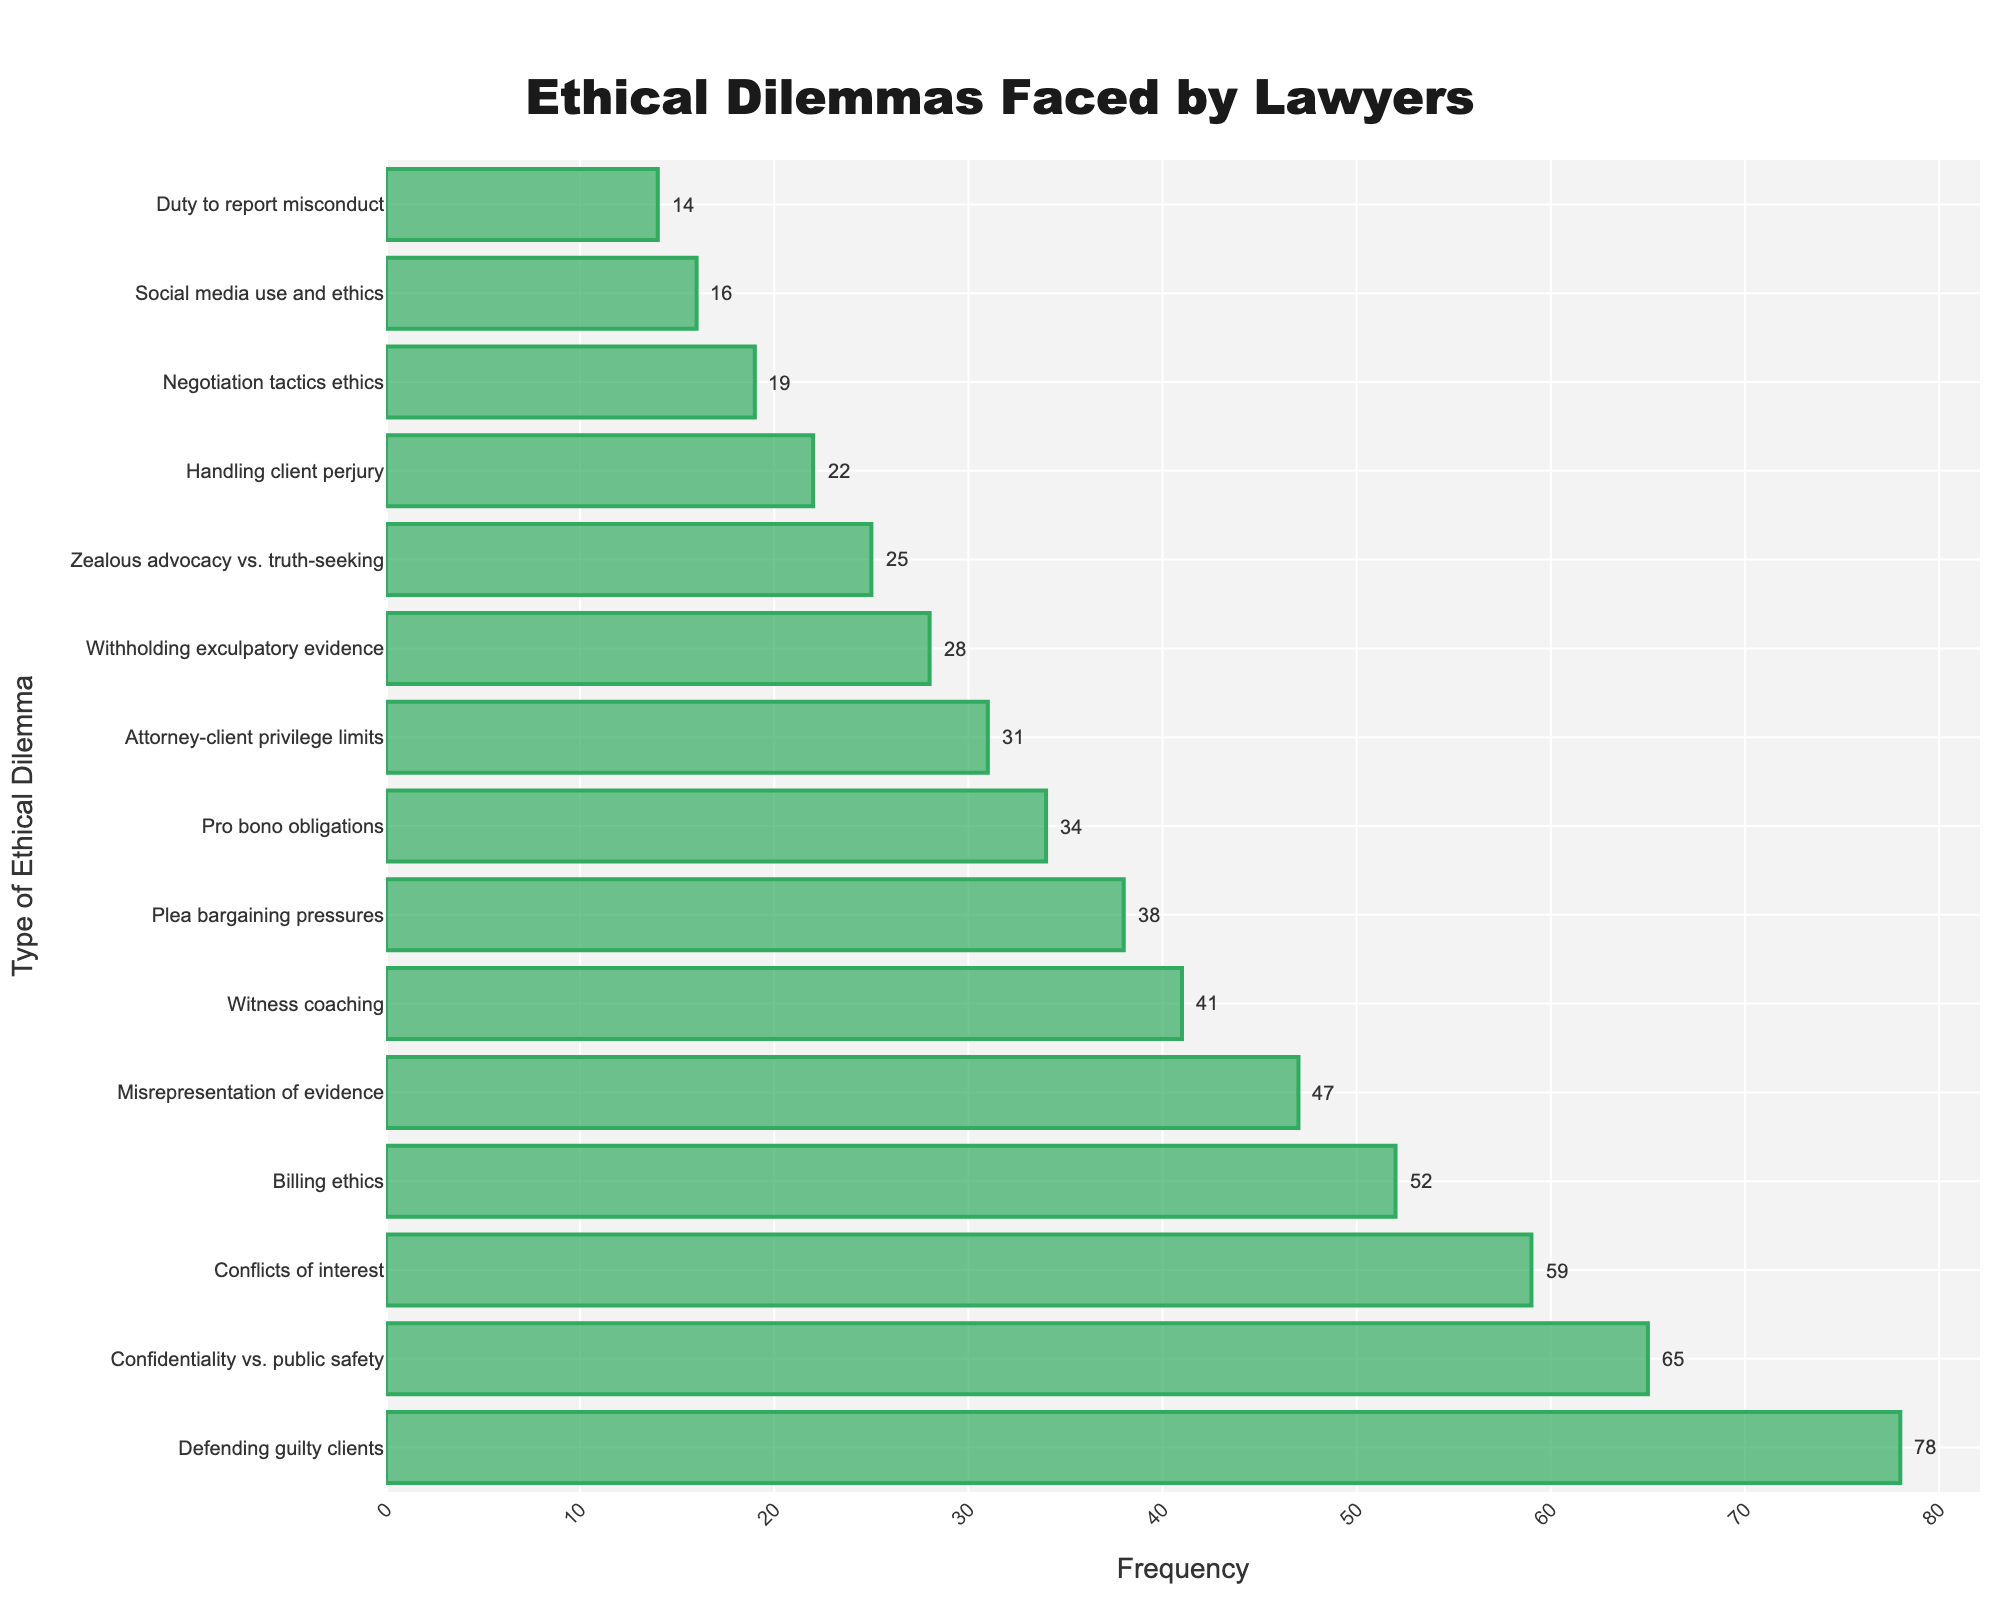Which ethical dilemma has the highest frequency? The bar representing "Defending guilty clients" is the longest bar, indicating it has the highest frequency.
Answer: Defending guilty clients What is the difference in frequency between "Defending guilty clients" and "Confidentiality vs. public safety"? The frequency for "Defending guilty clients" is 78 and for "Confidentiality vs. public safety" is 65. The difference is 78 - 65 = 13.
Answer: 13 How many ethical dilemmas have a frequency greater than 50? By observing the bars, the ethical dilemmas with frequencies greater than 50 are "Defending guilty clients," "Confidentiality vs. public safety," "Conflicts of interest," and "Billing ethics." There are 4 such dilemmas.
Answer: 4 What is the average frequency of the ethical dilemmas? Sum all the frequencies and divide by the number of dilemmas: (78 + 65 + 59 + 52 + 47 + 41 + 38 + 34 + 31 + 28 + 25 + 22 + 19 + 16 + 14) / 15 = 569 / 15 ≈ 37.93.
Answer: 37.93 How does the frequency of "Handling client perjury" compare to "Negotiation tactics ethics"? The frequency of "Handling client perjury" is 22, and for "Negotiation tactics ethics" it is 19. 22 is greater than 19 by 3.
Answer: Handling client perjury is greater by 3 What is the median frequency of the ethical dilemmas? After sorting the frequencies in ascending order (14, 16, 19, 22, 25, 28, 31, 34, 38, 41, 47, 52, 59, 65, 78), the median is the middle value: 34.
Answer: 34 What proportion of the ethical dilemmas have a frequency less than 30? Ethical dilemmas with frequencies less than 30 are "Withholding exculpatory evidence," "Zealous advocacy vs. truth-seeking," "Handling client perjury," "Negotiation tactics ethics," "Social media use and ethics," and "Duty to report misconduct." Out of 15 dilemmas, 6 are less than 30. Proportion is 6/15 = 0.4.
Answer: 0.4 Which ethical dilemma is represented by the shortest bar? The shortest bar on the chart represents the "Duty to report misconduct" with a frequency of 14.
Answer: Duty to report misconduct How much more frequent is "Witness coaching" compared to "Social media use and ethics"? "Witness coaching" has a frequency of 41, and "Social media use and ethics" has a frequency of 16. The difference is 41 - 16 = 25.
Answer: 25 What is the cumulative frequency of the top three most common ethical dilemmas? The top three are "Defending guilty clients" (78), "Confidentiality vs. public safety" (65), and "Conflicts of interest" (59). Their cumulative frequency is 78 + 65 + 59 = 202.
Answer: 202 